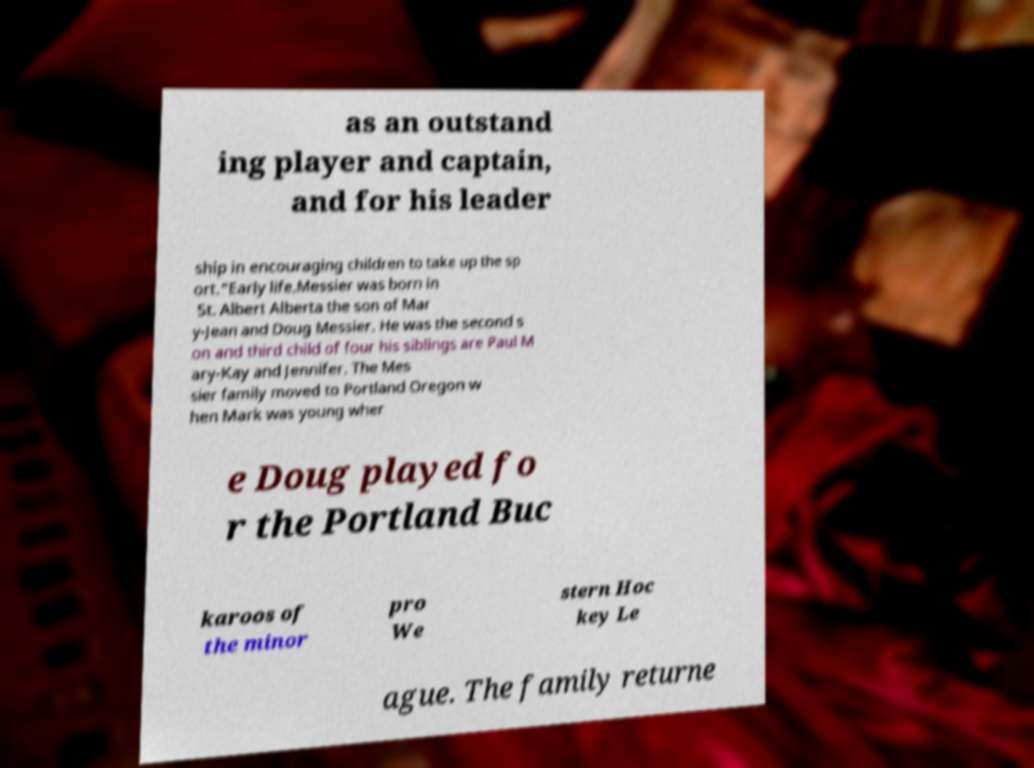For documentation purposes, I need the text within this image transcribed. Could you provide that? as an outstand ing player and captain, and for his leader ship in encouraging children to take up the sp ort."Early life.Messier was born in St. Albert Alberta the son of Mar y-Jean and Doug Messier. He was the second s on and third child of four his siblings are Paul M ary-Kay and Jennifer. The Mes sier family moved to Portland Oregon w hen Mark was young wher e Doug played fo r the Portland Buc karoos of the minor pro We stern Hoc key Le ague. The family returne 